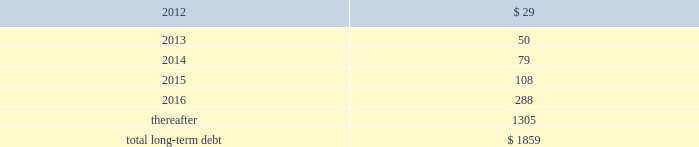Performance of the company 2019s obligations under the senior notes , including any repurchase obligations resulting from a change of control , is unconditionally guaranteed , jointly and severally , on an unsecured basis , by each of hii 2019s existing and future domestic restricted subsidiaries that guarantees debt under the credit facility ( the 201csubsidiary guarantors 201d ) .
The guarantees rank equally with all other unsecured and unsubordinated indebtedness of the guarantors .
The subsidiary guarantors are each directly or indirectly 100% ( 100 % ) owned by hii .
There are no significant restrictions on the ability of hii or any subsidiary guarantor to obtain funds from their respective subsidiaries by dividend or loan .
Mississippi economic development revenue bonds 2014as of december 31 , 2011 and 2010 , the company had $ 83.7 million outstanding from the issuance of industrial revenue bonds issued by the mississippi business finance corporation .
These bonds accrue interest at a fixed rate of 7.81% ( 7.81 % ) per annum ( payable semi-annually ) and mature in 2024 .
While repayment of principal and interest is guaranteed by northrop grumman systems corporation , hii has agreed to indemnify northrop grumman systems corporation for any losses related to the guaranty .
In accordance with the terms of the bonds , the proceeds have been used to finance the construction , reconstruction , and renovation of the company 2019s interest in certain ship manufacturing and repair facilities , or portions thereof , located in the state of mississippi .
Gulf opportunity zone industrial development revenue bonds 2014as of december 31 , 2011 and 2010 , the company had $ 21.6 million outstanding from the issuance of gulf opportunity zone industrial development revenue bonds ( 201cgo zone irbs 201d ) issued by the mississippi business finance corporation .
The go zone irbs were initially issued in a principal amount of $ 200 million , and in november 2010 , in connection with the anticipated spin-off , hii purchased $ 178 million of the bonds using the proceeds from a $ 178 million intercompany loan from northrop grumman .
See note 20 : related party transactions and former parent company equity .
The remaining bonds accrue interest at a fixed rate of 4.55% ( 4.55 % ) per annum ( payable semi-annually ) , and mature in 2028 .
In accordance with the terms of the bonds , the proceeds have been used to finance the construction , reconstruction , and renovation of the company 2019s interest in certain ship manufacturing and repair facilities , or portions thereof , located in the state of mississippi .
The estimated fair value of the company 2019s total long-term debt , including current portions , at december 31 , 2011 and 2010 , was $ 1864 million and $ 128 million , respectively .
The fair value of the total long-term debt was calculated based on recent trades for most of the company 2019s debt instruments or based on interest rates prevailing on debt with substantially similar risks , terms and maturities .
The aggregate amounts of principal payments due on long-term debt for each of the next five years and thereafter are : ( $ in millions ) .
14 .
Investigations , claims , and litigation the company is involved in legal proceedings before various courts and administrative agencies , and is periodically subject to government examinations , inquiries and investigations .
Pursuant to fasb accounting standard codification 450 contingencies , the company has accrued for losses associated with investigations , claims and litigation when , and to the extent that , loss amounts related to the investigations , claims and litigation are probable and can be reasonably estimated .
The actual losses that might be incurred to resolve such investigations , claims and litigation may be higher or lower than the amounts accrued .
For matters where a material loss is probable or reasonably possible and the amount of loss cannot be reasonably estimated , but the company is able to reasonably estimate a range of possible losses , such estimated range is required to be disclosed in these notes .
This estimated range would be based on information currently available to the company and would involve elements of judgment and significant uncertainties .
This estimated range of possible loss would not represent the company 2019s maximum possible loss exposure .
For matters as to which the company is not able to reasonably estimate a possible loss or range of loss , the company is required to indicate the reasons why it is unable to estimate the possible loss or range of loss .
For matters not specifically described in these notes , the company does not believe , based on information currently available to it , that it is reasonably possible that the liabilities , if any , arising from .
What was the ratio of the estimated fair value of the company 2019s total long-term debt , including current portions , at december 31 for 2011 compared to 2010? 
Rationale: for every dollar of the estimated fair value of the company 2019s total long-term debt , including current portions , at december 31 in 2010 , there was $ 14.56 in 2010
Computations: (1864 / 128)
Answer: 14.5625. 